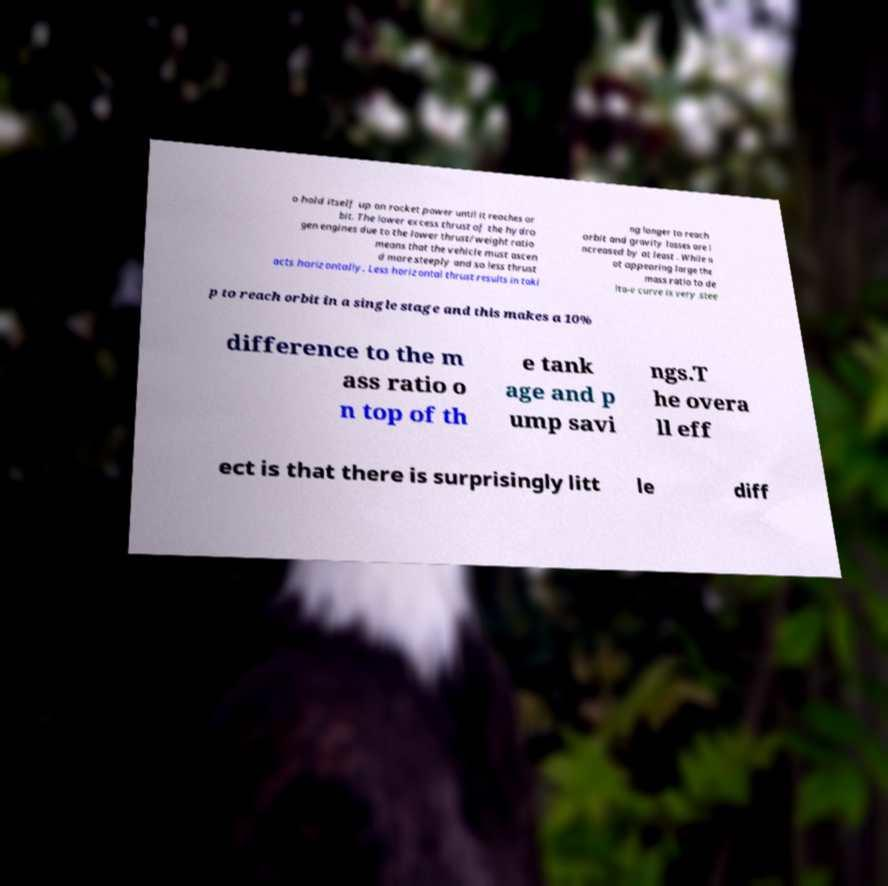Could you extract and type out the text from this image? o hold itself up on rocket power until it reaches or bit. The lower excess thrust of the hydro gen engines due to the lower thrust/weight ratio means that the vehicle must ascen d more steeply and so less thrust acts horizontally. Less horizontal thrust results in taki ng longer to reach orbit and gravity losses are i ncreased by at least . While n ot appearing large the mass ratio to de lta-v curve is very stee p to reach orbit in a single stage and this makes a 10% difference to the m ass ratio o n top of th e tank age and p ump savi ngs.T he overa ll eff ect is that there is surprisingly litt le diff 